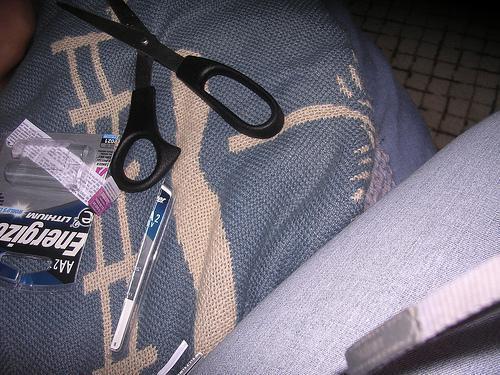How many scissors are there?
Give a very brief answer. 1. 